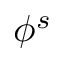Convert formula to latex. <formula><loc_0><loc_0><loc_500><loc_500>\phi ^ { s }</formula> 